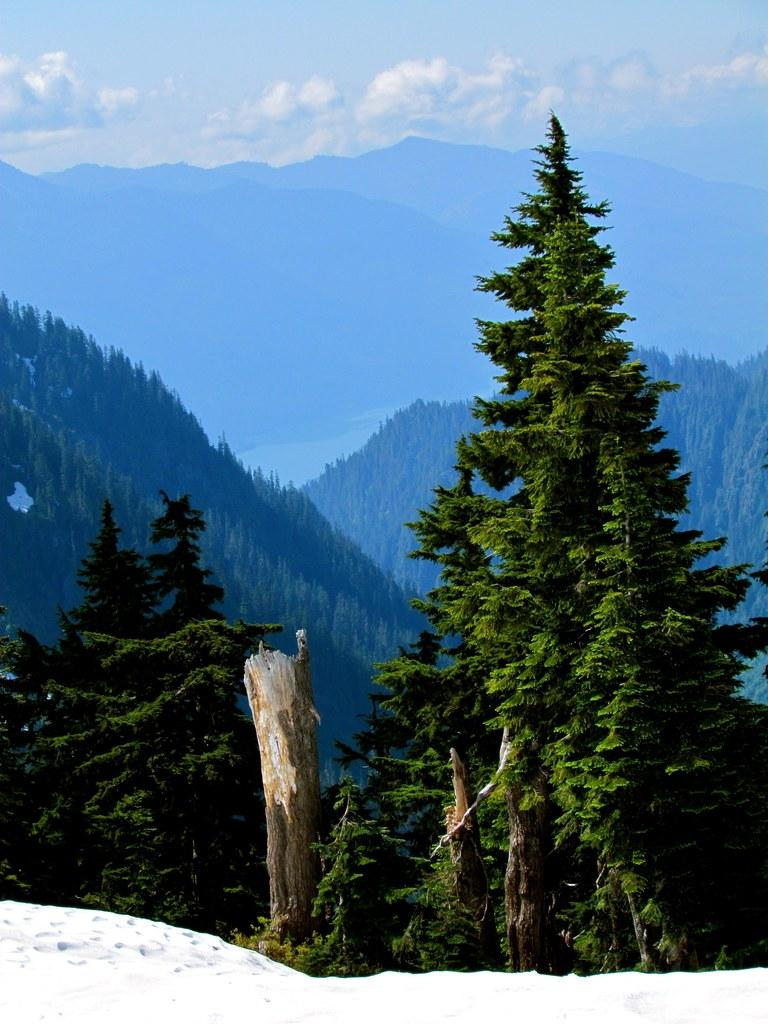What is covering the surface in the image? There is snow on the surface in the image. What can be seen in the background of the image? There are trees and mountains in the background of the image. What type of cannon can be seen in the image? There is no cannon present in the image. What kind of stone is used to build the mountains in the image? The image does not provide information about the type of stone used to build the mountains. 